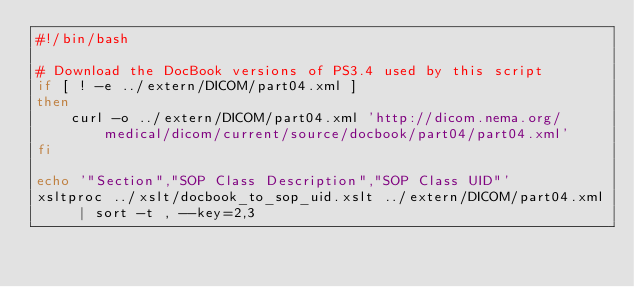Convert code to text. <code><loc_0><loc_0><loc_500><loc_500><_Bash_>#!/bin/bash

# Download the DocBook versions of PS3.4 used by this script
if [ ! -e ../extern/DICOM/part04.xml ]
then
    curl -o ../extern/DICOM/part04.xml 'http://dicom.nema.org/medical/dicom/current/source/docbook/part04/part04.xml'
fi

echo '"Section","SOP Class Description","SOP Class UID"'
xsltproc ../xslt/docbook_to_sop_uid.xslt ../extern/DICOM/part04.xml | sort -t , --key=2,3
</code> 